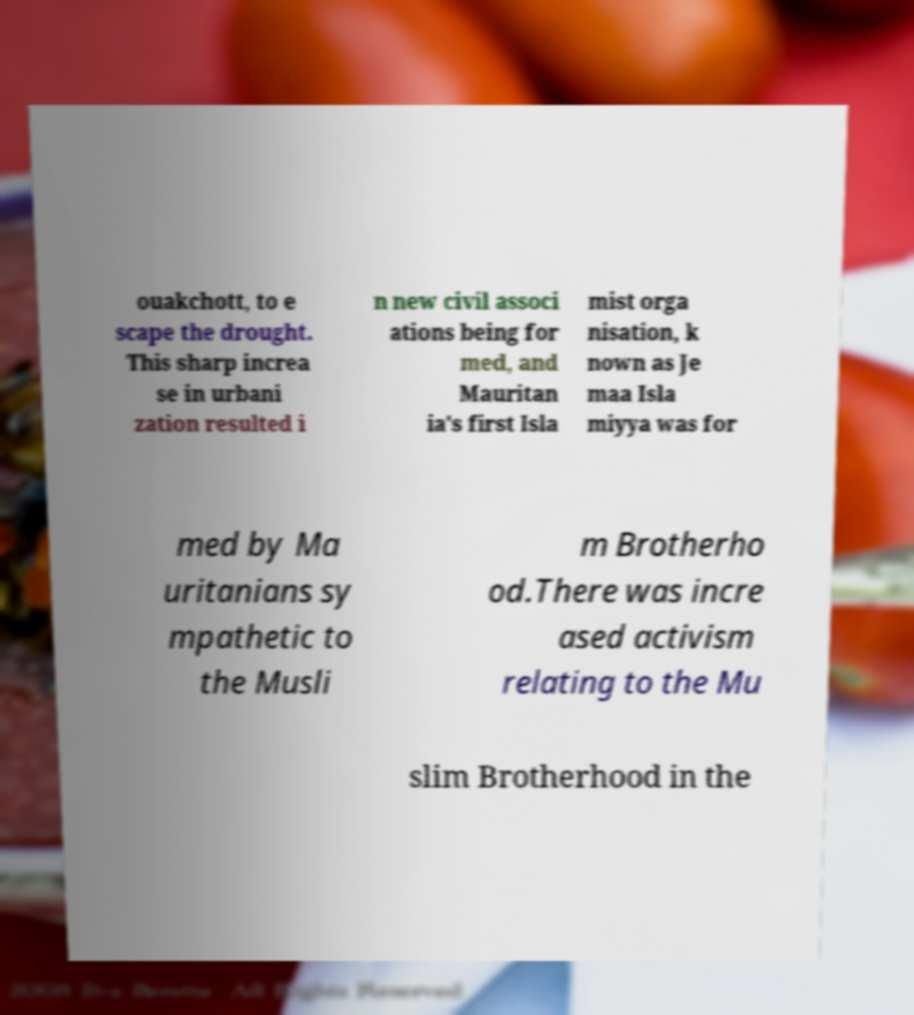Please read and relay the text visible in this image. What does it say? ouakchott, to e scape the drought. This sharp increa se in urbani zation resulted i n new civil associ ations being for med, and Mauritan ia's first Isla mist orga nisation, k nown as Je maa Isla miyya was for med by Ma uritanians sy mpathetic to the Musli m Brotherho od.There was incre ased activism relating to the Mu slim Brotherhood in the 